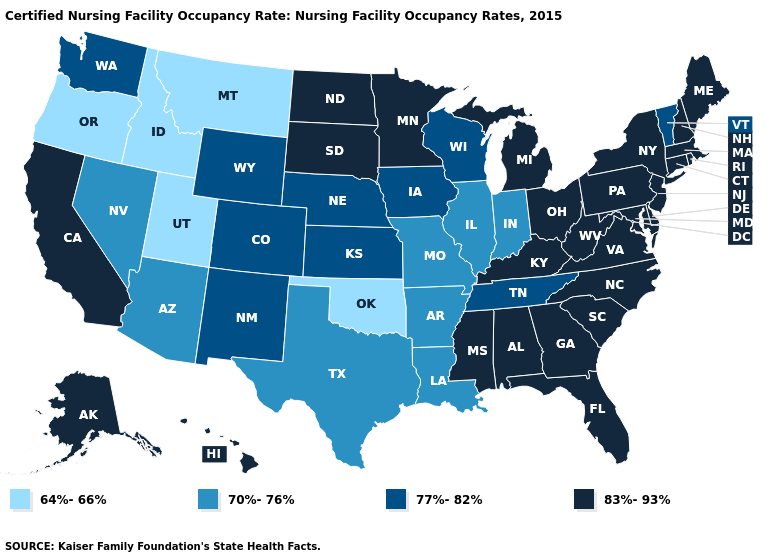Name the states that have a value in the range 70%-76%?
Short answer required. Arizona, Arkansas, Illinois, Indiana, Louisiana, Missouri, Nevada, Texas. Does Arkansas have the same value as California?
Be succinct. No. Name the states that have a value in the range 83%-93%?
Keep it brief. Alabama, Alaska, California, Connecticut, Delaware, Florida, Georgia, Hawaii, Kentucky, Maine, Maryland, Massachusetts, Michigan, Minnesota, Mississippi, New Hampshire, New Jersey, New York, North Carolina, North Dakota, Ohio, Pennsylvania, Rhode Island, South Carolina, South Dakota, Virginia, West Virginia. What is the value of New Jersey?
Write a very short answer. 83%-93%. Among the states that border Oklahoma , does Kansas have the lowest value?
Concise answer only. No. What is the value of Nebraska?
Concise answer only. 77%-82%. What is the value of Vermont?
Keep it brief. 77%-82%. What is the highest value in the USA?
Answer briefly. 83%-93%. What is the value of Virginia?
Concise answer only. 83%-93%. Does Michigan have the lowest value in the MidWest?
Be succinct. No. Name the states that have a value in the range 64%-66%?
Quick response, please. Idaho, Montana, Oklahoma, Oregon, Utah. Which states hav the highest value in the MidWest?
Keep it brief. Michigan, Minnesota, North Dakota, Ohio, South Dakota. How many symbols are there in the legend?
Give a very brief answer. 4. 